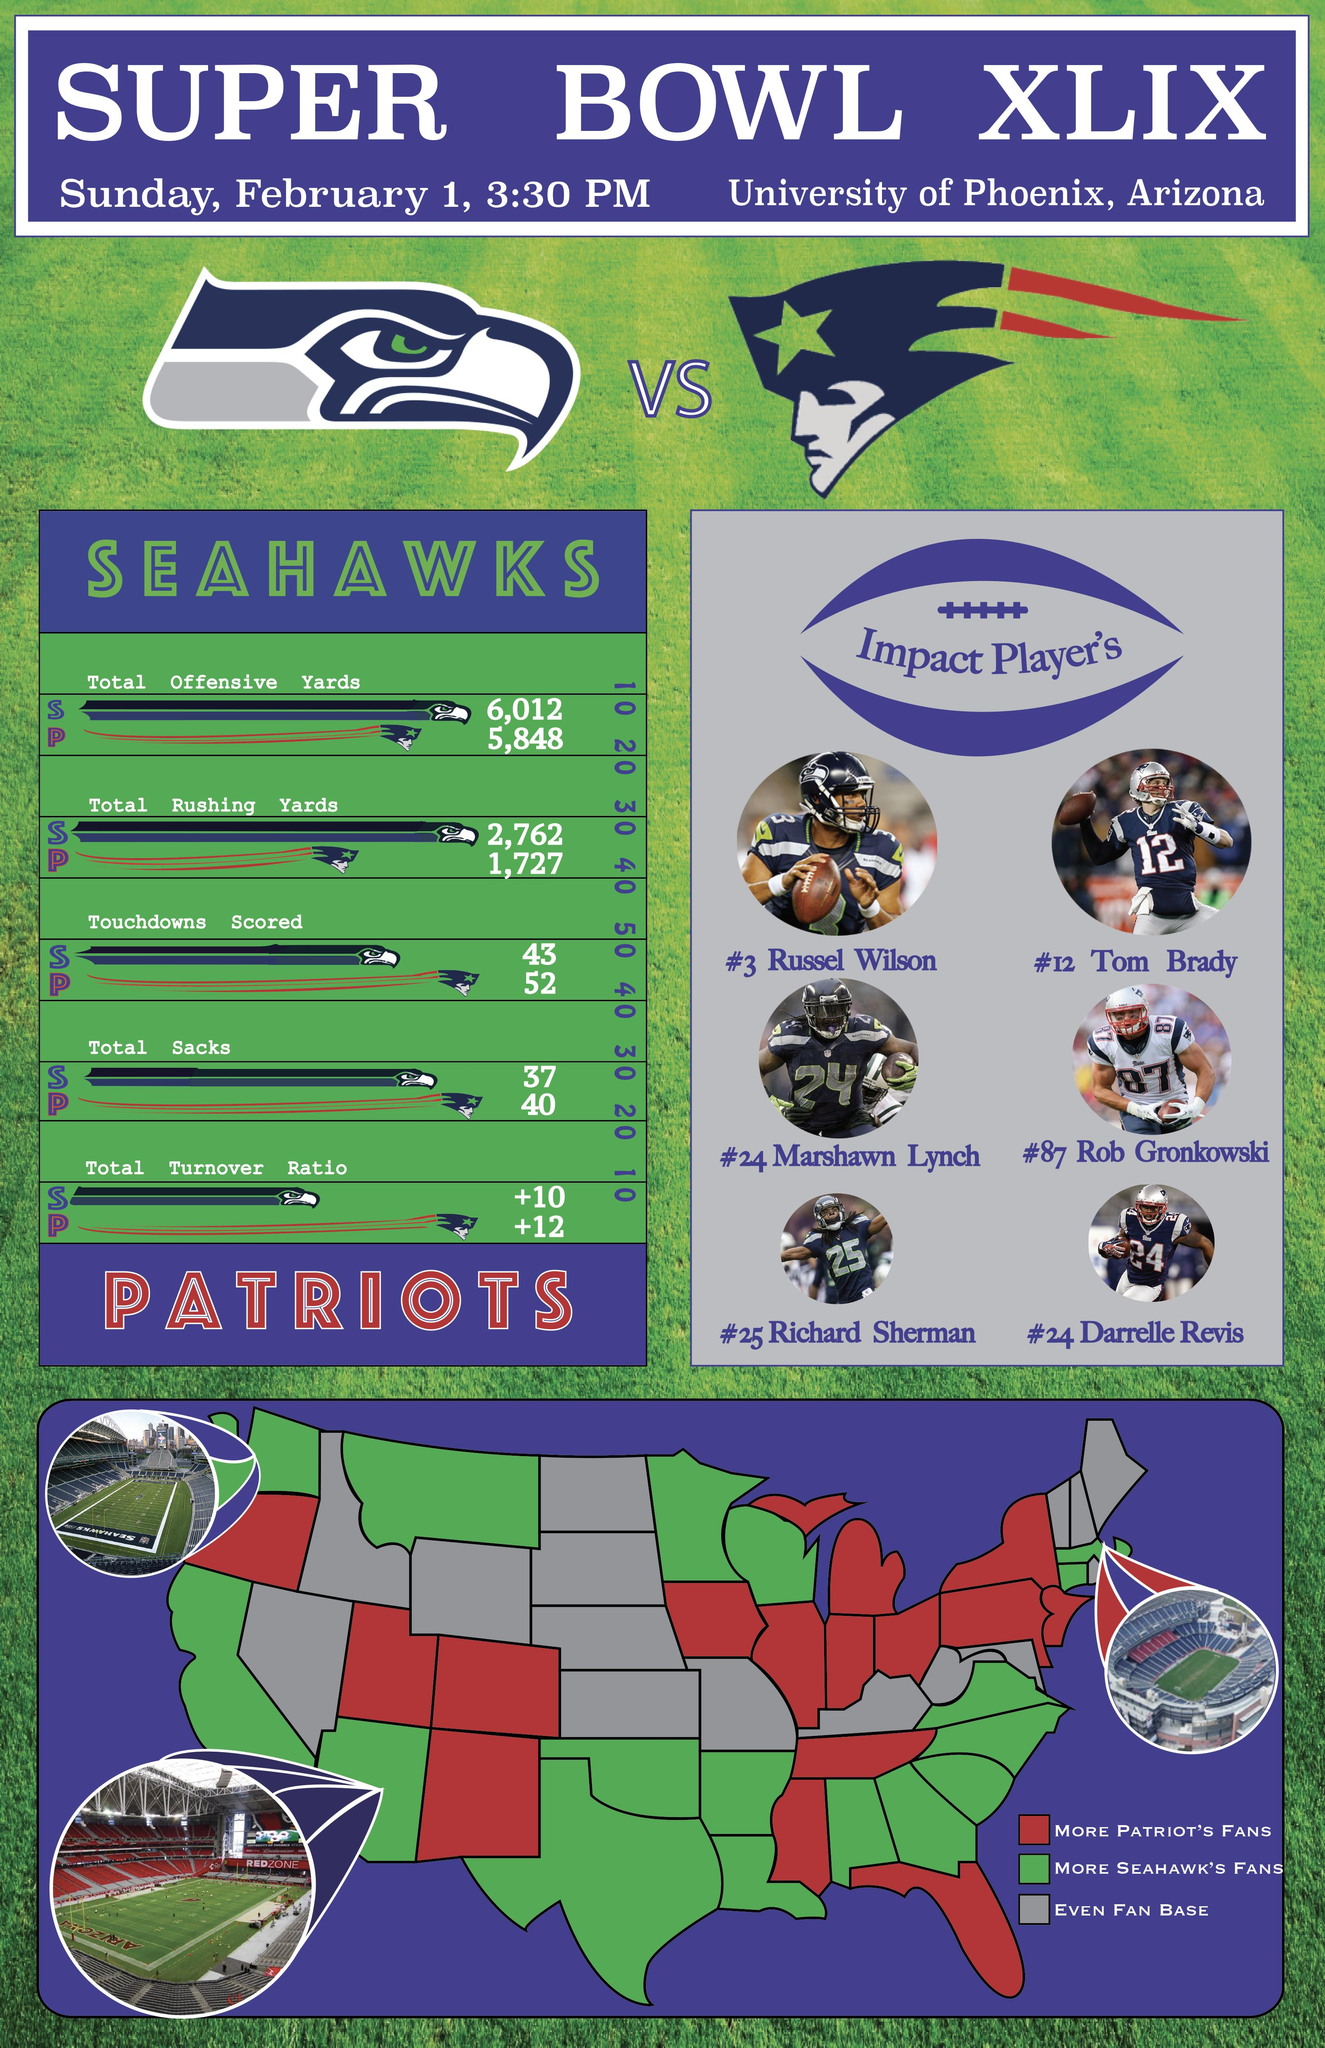List a handful of essential elements in this visual. The Seahawks had a higher total offensive and rushing yards than the other team. The University of Phoenix Stadium is displayed on the left bottom of the map. The Patriots have a higher total of touchdowns, sacks, and turnover ratio than any other team. There were 16 states in which the Seattle Seahawks fans outnumbered New England Patriots fans. Seventeen states had a larger number of fans who supported the Seattle Seahawks football team. 